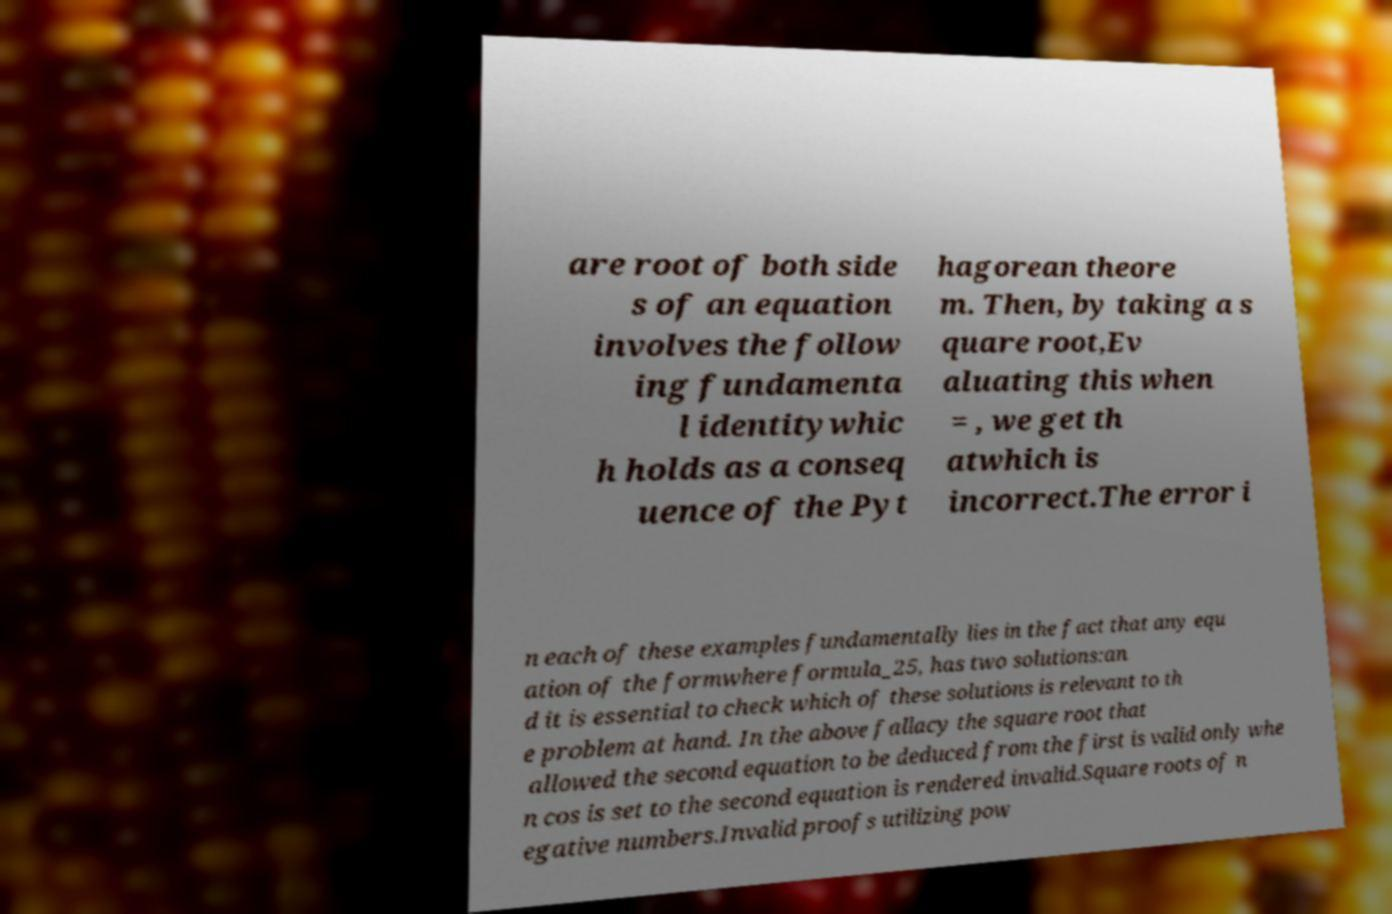Could you assist in decoding the text presented in this image and type it out clearly? are root of both side s of an equation involves the follow ing fundamenta l identitywhic h holds as a conseq uence of the Pyt hagorean theore m. Then, by taking a s quare root,Ev aluating this when = , we get th atwhich is incorrect.The error i n each of these examples fundamentally lies in the fact that any equ ation of the formwhere formula_25, has two solutions:an d it is essential to check which of these solutions is relevant to th e problem at hand. In the above fallacy the square root that allowed the second equation to be deduced from the first is valid only whe n cos is set to the second equation is rendered invalid.Square roots of n egative numbers.Invalid proofs utilizing pow 